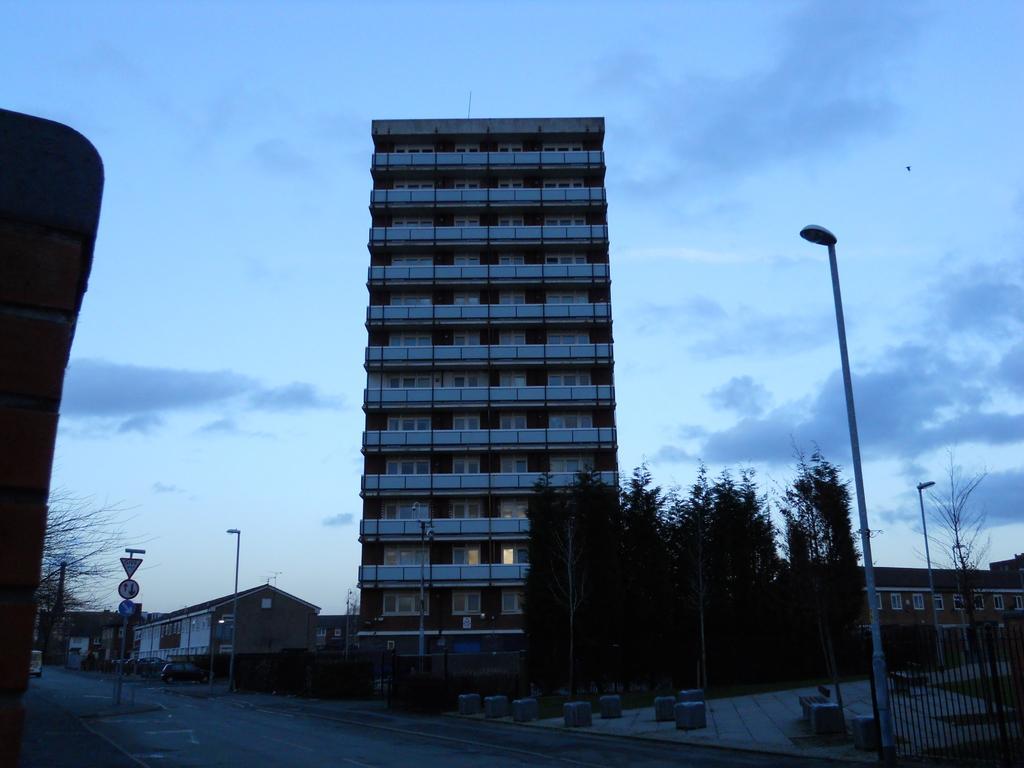Describe this image in one or two sentences. In this image, we can see a building, houses, trees, poles, sign boards, vehicles, plant, road and grill. Background there is a sky. 